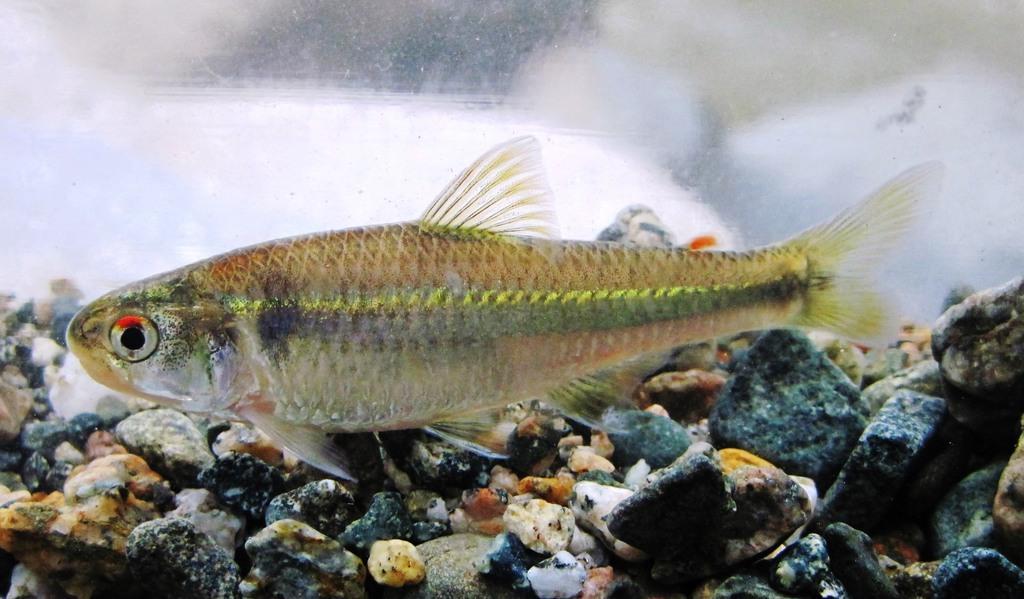In one or two sentences, can you explain what this image depicts? It seems like a water body and here we can see a fish and at the bottom, there are stones. 